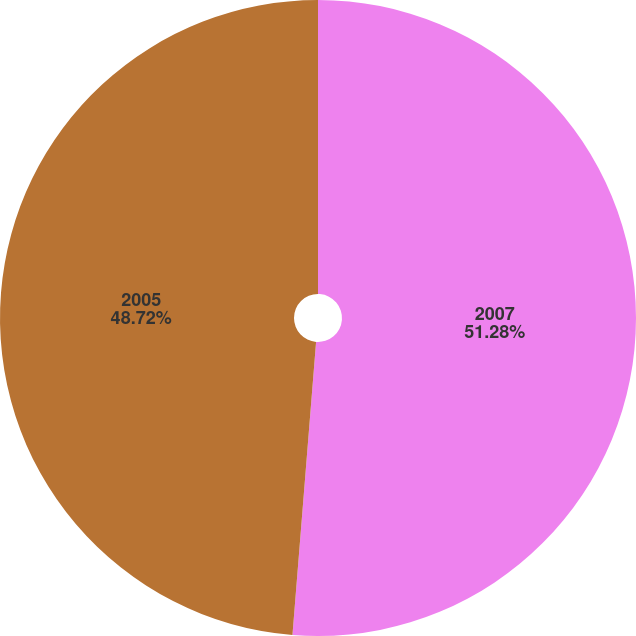Convert chart. <chart><loc_0><loc_0><loc_500><loc_500><pie_chart><fcel>2007<fcel>2005<nl><fcel>51.28%<fcel>48.72%<nl></chart> 